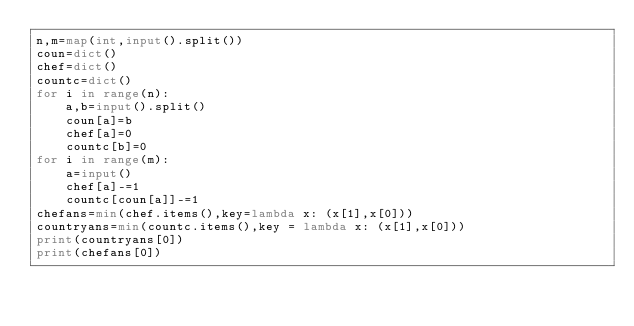<code> <loc_0><loc_0><loc_500><loc_500><_Python_>n,m=map(int,input().split())
coun=dict()
chef=dict()
countc=dict()
for i in range(n):
    a,b=input().split()
    coun[a]=b
    chef[a]=0
    countc[b]=0
for i in range(m):
    a=input()
    chef[a]-=1
    countc[coun[a]]-=1
chefans=min(chef.items(),key=lambda x: (x[1],x[0]))
countryans=min(countc.items(),key = lambda x: (x[1],x[0]))
print(countryans[0])
print(chefans[0])

</code> 